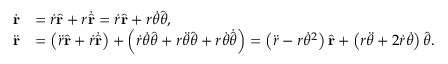<formula> <loc_0><loc_0><loc_500><loc_500>{ \begin{array} { r l } { { \dot { r } } } & { = { \dot { r } } { \hat { r } } + r { \dot { \hat { r } } } = { \dot { r } } { \hat { r } } + r { \dot { \theta } } { \hat { \theta } } , } \\ { { \ddot { r } } } & { = \left ( { \ddot { r } } { \hat { r } } + { \dot { r } } { \dot { \hat { r } } } \right ) + \left ( { \dot { r } } { \dot { \theta } } { \hat { \theta } } + r { \ddot { \theta } } { \hat { \theta } } + r { \dot { \theta } } { \dot { \hat { \theta } } } \right ) = \left ( { \ddot { r } } - r { \dot { \theta } } ^ { 2 } \right ) { \hat { r } } + \left ( r { \ddot { \theta } } + 2 { \dot { r } } { \dot { \theta } } \right ) { \hat { \theta } } . } \end{array} }</formula> 